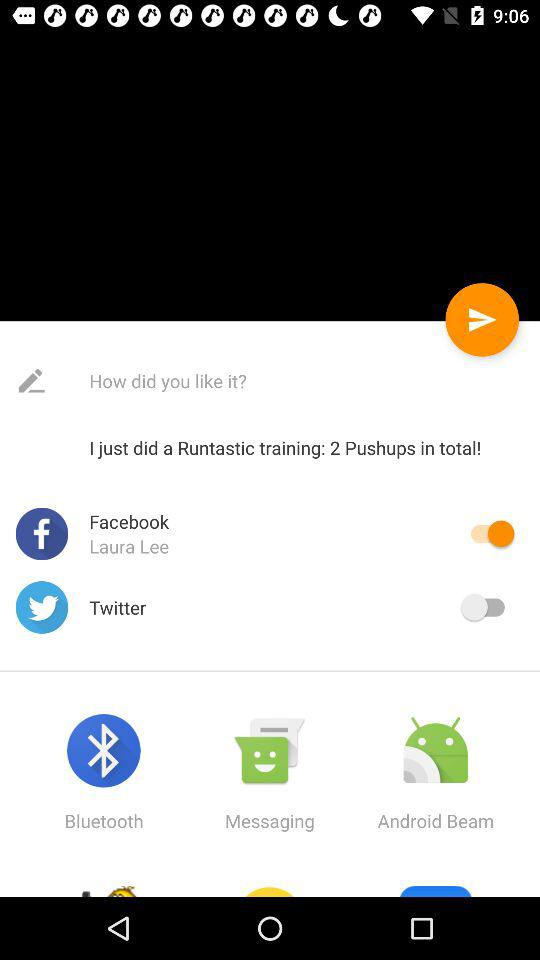What is the status of "Facebook"? The status is "on". 